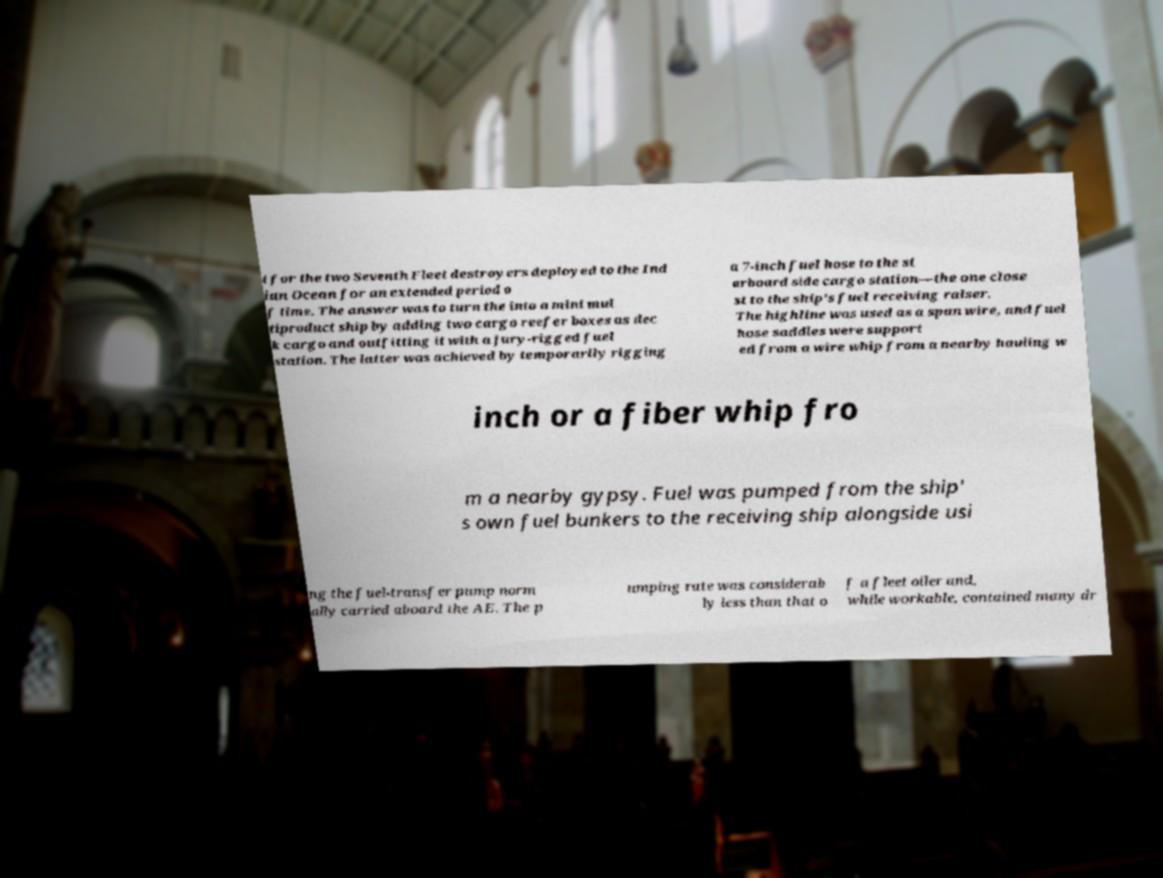For documentation purposes, I need the text within this image transcribed. Could you provide that? t for the two Seventh Fleet destroyers deployed to the Ind ian Ocean for an extended period o f time. The answer was to turn the into a mini mul tiproduct ship by adding two cargo reefer boxes as dec k cargo and outfitting it with a jury-rigged fuel station. The latter was achieved by temporarily rigging a 7-inch fuel hose to the st arboard side cargo station—the one close st to the ship's fuel receiving raiser. The highline was used as a span wire, and fuel hose saddles were support ed from a wire whip from a nearby hauling w inch or a fiber whip fro m a nearby gypsy. Fuel was pumped from the ship' s own fuel bunkers to the receiving ship alongside usi ng the fuel-transfer pump norm ally carried aboard the AE. The p umping rate was considerab ly less than that o f a fleet oiler and, while workable, contained many dr 